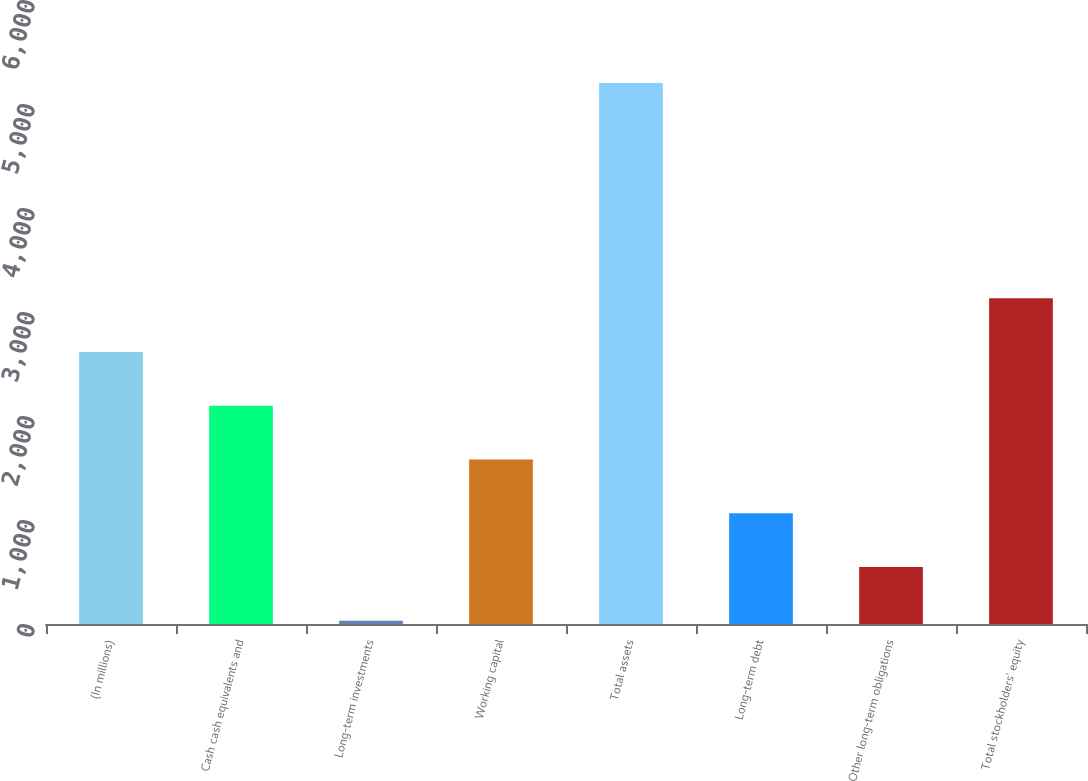<chart> <loc_0><loc_0><loc_500><loc_500><bar_chart><fcel>(In millions)<fcel>Cash cash equivalents and<fcel>Long-term investments<fcel>Working capital<fcel>Total assets<fcel>Long-term debt<fcel>Other long-term obligations<fcel>Total stockholders' equity<nl><fcel>2616<fcel>2099<fcel>31<fcel>1582<fcel>5201<fcel>1065<fcel>548<fcel>3133<nl></chart> 